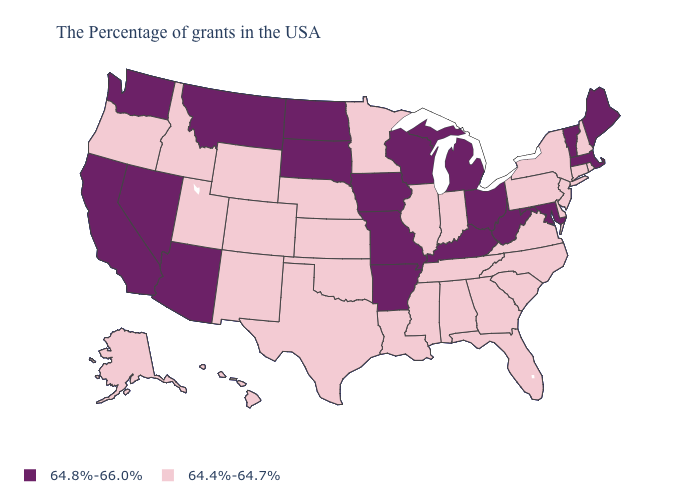Name the states that have a value in the range 64.8%-66.0%?
Keep it brief. Maine, Massachusetts, Vermont, Maryland, West Virginia, Ohio, Michigan, Kentucky, Wisconsin, Missouri, Arkansas, Iowa, South Dakota, North Dakota, Montana, Arizona, Nevada, California, Washington. Which states have the highest value in the USA?
Be succinct. Maine, Massachusetts, Vermont, Maryland, West Virginia, Ohio, Michigan, Kentucky, Wisconsin, Missouri, Arkansas, Iowa, South Dakota, North Dakota, Montana, Arizona, Nevada, California, Washington. What is the lowest value in the USA?
Keep it brief. 64.4%-64.7%. Which states have the lowest value in the USA?
Give a very brief answer. Rhode Island, New Hampshire, Connecticut, New York, New Jersey, Delaware, Pennsylvania, Virginia, North Carolina, South Carolina, Florida, Georgia, Indiana, Alabama, Tennessee, Illinois, Mississippi, Louisiana, Minnesota, Kansas, Nebraska, Oklahoma, Texas, Wyoming, Colorado, New Mexico, Utah, Idaho, Oregon, Alaska, Hawaii. Name the states that have a value in the range 64.4%-64.7%?
Write a very short answer. Rhode Island, New Hampshire, Connecticut, New York, New Jersey, Delaware, Pennsylvania, Virginia, North Carolina, South Carolina, Florida, Georgia, Indiana, Alabama, Tennessee, Illinois, Mississippi, Louisiana, Minnesota, Kansas, Nebraska, Oklahoma, Texas, Wyoming, Colorado, New Mexico, Utah, Idaho, Oregon, Alaska, Hawaii. How many symbols are there in the legend?
Keep it brief. 2. What is the highest value in the USA?
Short answer required. 64.8%-66.0%. Does Mississippi have a lower value than New Mexico?
Short answer required. No. What is the value of Oregon?
Quick response, please. 64.4%-64.7%. What is the highest value in the Northeast ?
Write a very short answer. 64.8%-66.0%. Does Colorado have a lower value than South Carolina?
Be succinct. No. How many symbols are there in the legend?
Quick response, please. 2. Does Mississippi have a lower value than Virginia?
Answer briefly. No. Among the states that border Nebraska , does Missouri have the lowest value?
Short answer required. No. Does New Mexico have the highest value in the USA?
Short answer required. No. 